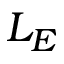<formula> <loc_0><loc_0><loc_500><loc_500>L _ { E }</formula> 